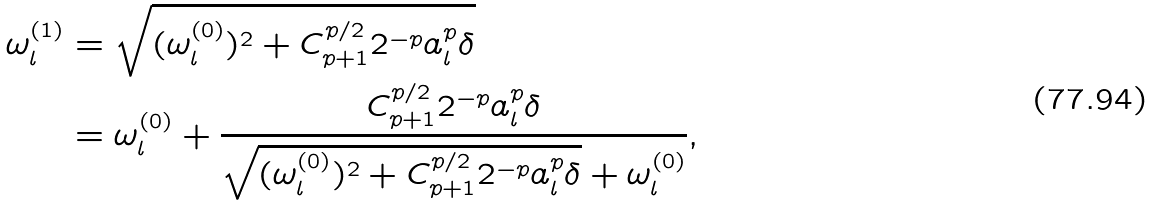Convert formula to latex. <formula><loc_0><loc_0><loc_500><loc_500>\omega _ { l } ^ { ( 1 ) } & = \sqrt { ( \omega _ { l } ^ { ( 0 ) } ) ^ { 2 } + C _ { p + 1 } ^ { p / 2 } 2 ^ { - p } a _ { l } ^ { p } \delta } \\ & = \omega _ { l } ^ { ( 0 ) } + \frac { C _ { p + 1 } ^ { p / 2 } 2 ^ { - p } a _ { l } ^ { p } \delta } { \sqrt { ( \omega _ { l } ^ { ( 0 ) } ) ^ { 2 } + C _ { p + 1 } ^ { p / 2 } 2 ^ { - p } a _ { l } ^ { p } \delta } + \omega _ { l } ^ { ( 0 ) } } ,</formula> 